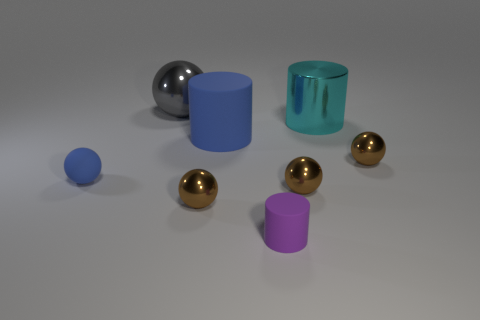What shape is the small matte object that is left of the small purple rubber cylinder?
Offer a very short reply. Sphere. There is a small matte thing to the right of the object that is left of the big gray object; how many brown metallic balls are left of it?
Your answer should be very brief. 1. Is the color of the small sphere left of the big gray metallic thing the same as the large rubber thing?
Your answer should be compact. Yes. What number of other things are the same shape as the gray thing?
Offer a very short reply. 4. How many other objects are the same material as the blue sphere?
Offer a terse response. 2. The big gray object left of the rubber thing that is right of the matte cylinder on the left side of the purple thing is made of what material?
Make the answer very short. Metal. Is the tiny purple thing made of the same material as the large blue cylinder?
Offer a terse response. Yes. How many balls are either big cyan metal things or tiny matte objects?
Offer a very short reply. 1. What color is the tiny matte thing that is behind the small purple rubber thing?
Provide a succinct answer. Blue. What number of metallic things are either purple things or large gray objects?
Your answer should be compact. 1. 